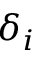<formula> <loc_0><loc_0><loc_500><loc_500>\delta _ { i }</formula> 